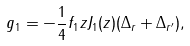Convert formula to latex. <formula><loc_0><loc_0><loc_500><loc_500>g _ { 1 } = - \frac { 1 } { 4 } f _ { 1 } z J _ { 1 } ( z ) ( \Delta _ { r } + \Delta _ { r ^ { \prime } } ) ,</formula> 